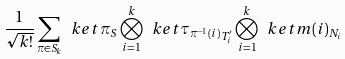<formula> <loc_0><loc_0><loc_500><loc_500>\frac { 1 } { \sqrt { k ! } } \sum _ { \pi \in S _ { k } } \ k e t { \pi } _ { S } \bigotimes _ { i = 1 } ^ { k } \ k e t { \tau _ { \pi ^ { - 1 } ( i ) } } _ { T _ { i } ^ { \prime } } \bigotimes _ { i = 1 } ^ { k } \ k e t { m ( i ) } _ { N _ { i } }</formula> 